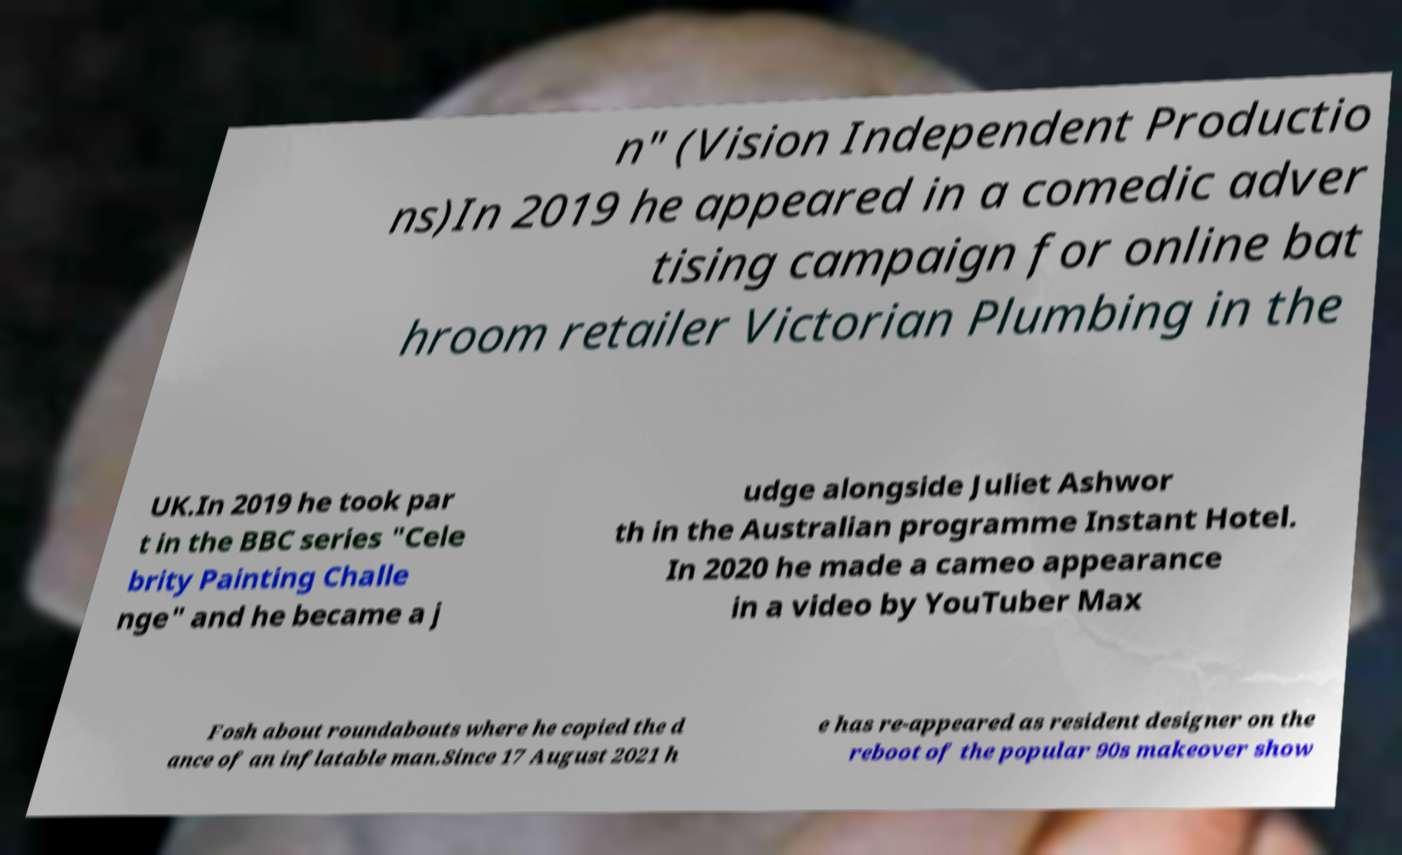Could you assist in decoding the text presented in this image and type it out clearly? n" (Vision Independent Productio ns)In 2019 he appeared in a comedic adver tising campaign for online bat hroom retailer Victorian Plumbing in the UK.In 2019 he took par t in the BBC series "Cele brity Painting Challe nge" and he became a j udge alongside Juliet Ashwor th in the Australian programme Instant Hotel. In 2020 he made a cameo appearance in a video by YouTuber Max Fosh about roundabouts where he copied the d ance of an inflatable man.Since 17 August 2021 h e has re-appeared as resident designer on the reboot of the popular 90s makeover show 